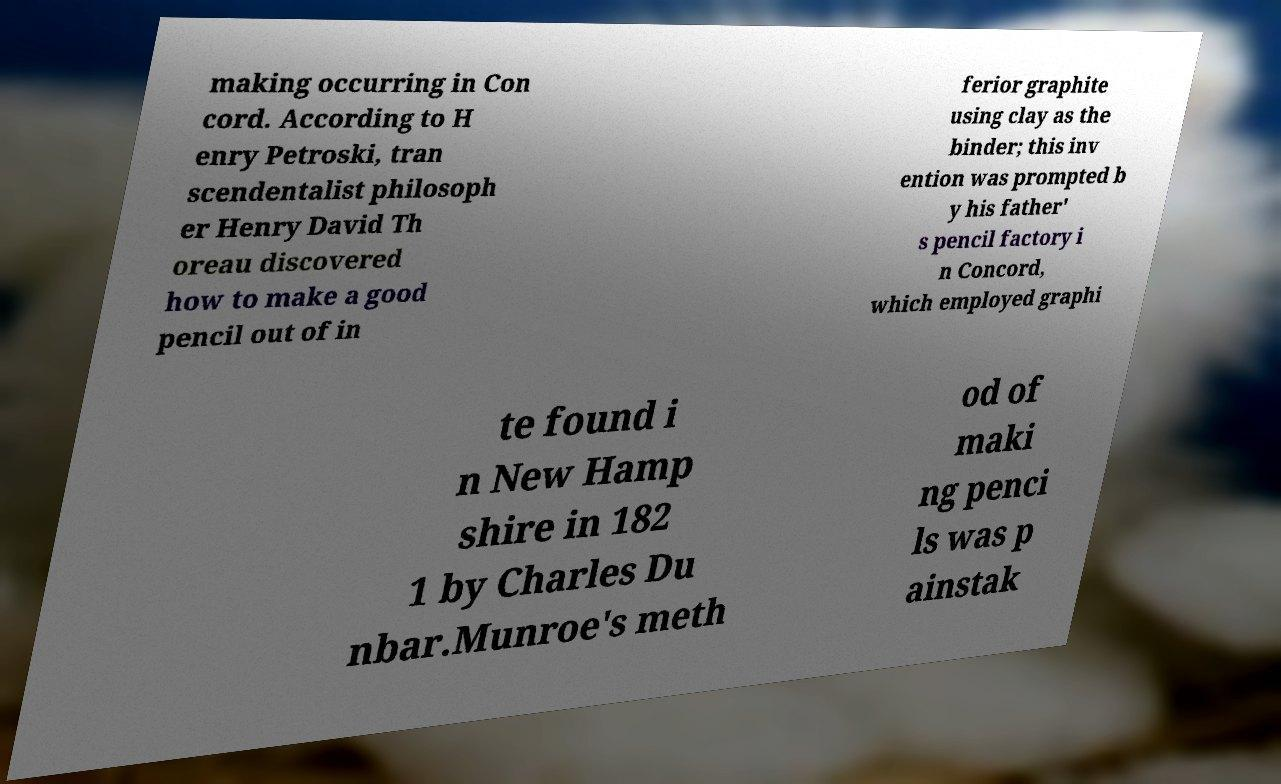Can you accurately transcribe the text from the provided image for me? making occurring in Con cord. According to H enry Petroski, tran scendentalist philosoph er Henry David Th oreau discovered how to make a good pencil out of in ferior graphite using clay as the binder; this inv ention was prompted b y his father' s pencil factory i n Concord, which employed graphi te found i n New Hamp shire in 182 1 by Charles Du nbar.Munroe's meth od of maki ng penci ls was p ainstak 